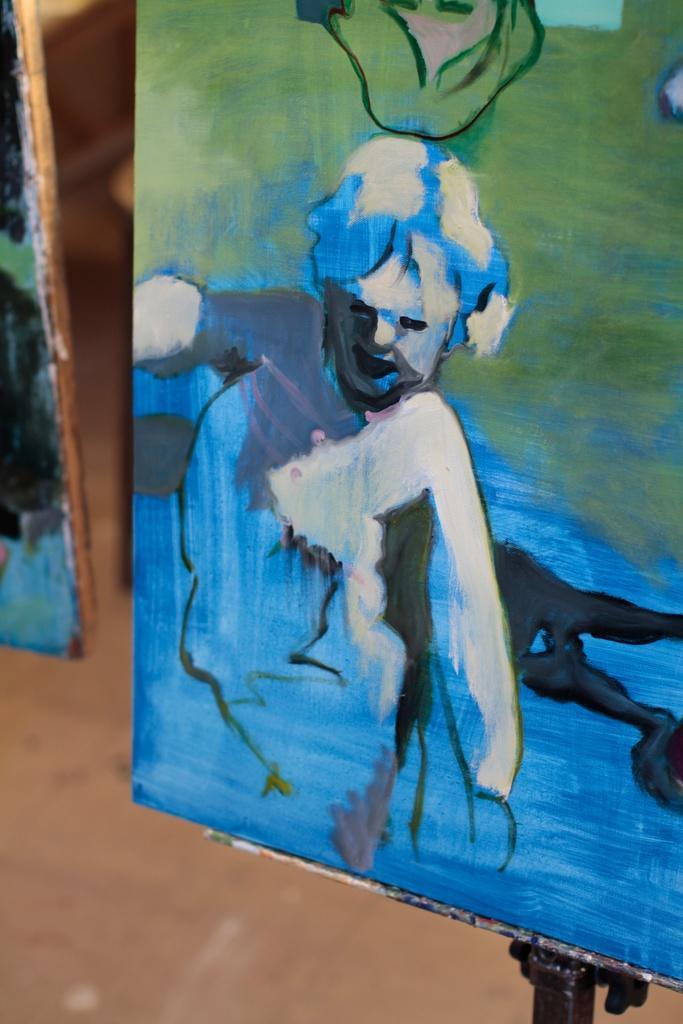Can you describe this image briefly? We can see boards,on this board we can see painting of a person and we can see floor. 